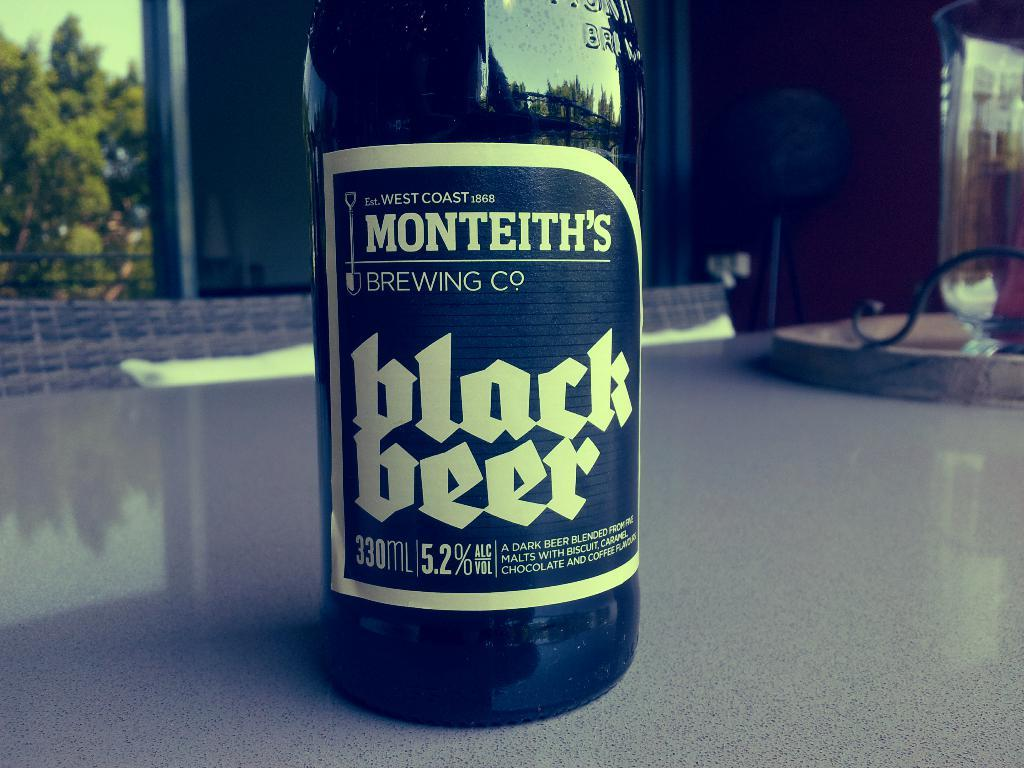<image>
Present a compact description of the photo's key features. A close up of a bottle of Monteith's Black Beer. 